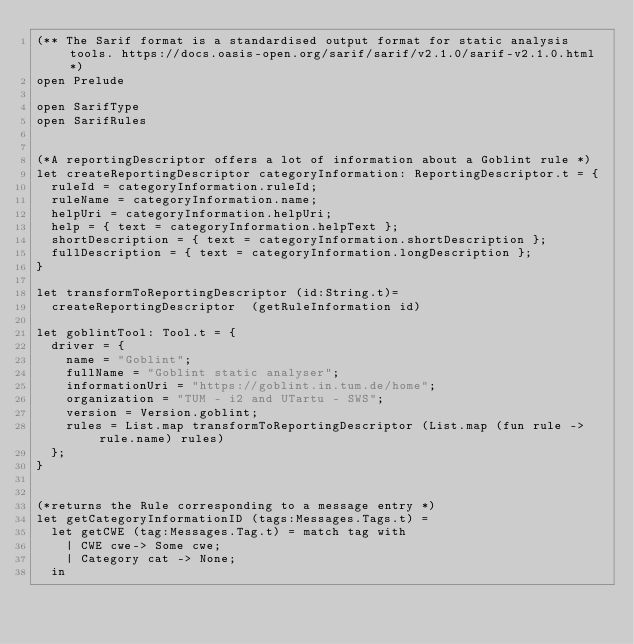<code> <loc_0><loc_0><loc_500><loc_500><_OCaml_>(** The Sarif format is a standardised output format for static analysis tools. https://docs.oasis-open.org/sarif/sarif/v2.1.0/sarif-v2.1.0.html *)
open Prelude

open SarifType
open SarifRules


(*A reportingDescriptor offers a lot of information about a Goblint rule *)
let createReportingDescriptor categoryInformation: ReportingDescriptor.t = {
  ruleId = categoryInformation.ruleId;
  ruleName = categoryInformation.name;
  helpUri = categoryInformation.helpUri;
  help = { text = categoryInformation.helpText };
  shortDescription = { text = categoryInformation.shortDescription };
  fullDescription = { text = categoryInformation.longDescription };
}

let transformToReportingDescriptor (id:String.t)=
  createReportingDescriptor  (getRuleInformation id)

let goblintTool: Tool.t = {
  driver = {
    name = "Goblint";
    fullName = "Goblint static analyser";
    informationUri = "https://goblint.in.tum.de/home";
    organization = "TUM - i2 and UTartu - SWS";
    version = Version.goblint;
    rules = List.map transformToReportingDescriptor (List.map (fun rule -> rule.name) rules)
  };
}


(*returns the Rule corresponding to a message entry *)
let getCategoryInformationID (tags:Messages.Tags.t) =
  let getCWE (tag:Messages.Tag.t) = match tag with
    | CWE cwe-> Some cwe;
    | Category cat -> None;
  in</code> 